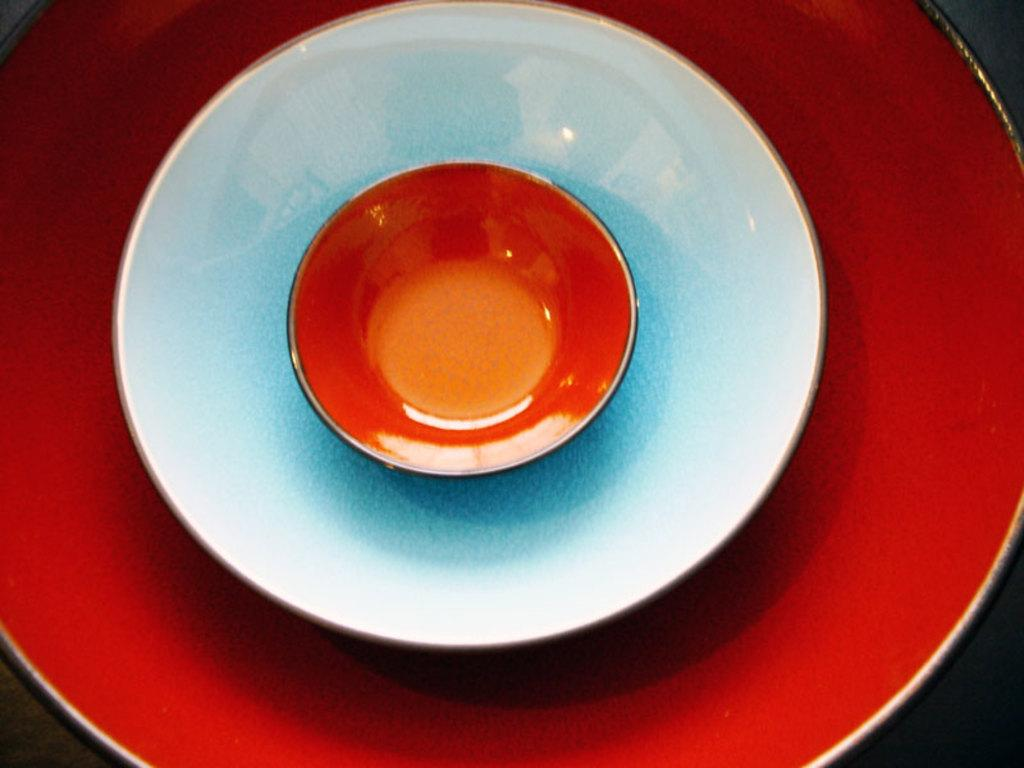How many objects are present in the image? There are three objects in the image. What is the shape of the objects? The objects are round in shape. What colors are the objects? The objects have red and white colors. What type of drug is visible in the image? There is no drug present in the image. Can you see a swing in the image? There is no swing present in the image. 